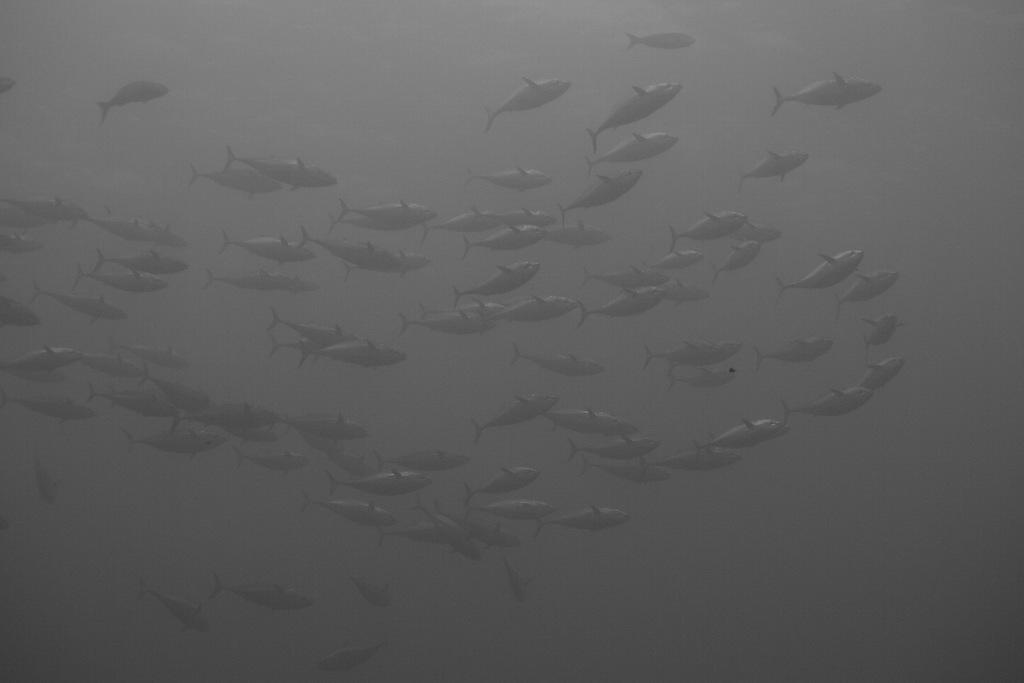What type of animals can be seen in the image? There are fishes visible in the image. How are the fishes arranged in the image? The fishes are in a group. What is the likely environment for the fishes in the image? The fishes are likely in water. What event is the father attending with his toe in the image? There is no event, father, or toe present in the image; it features a group of fishes. 